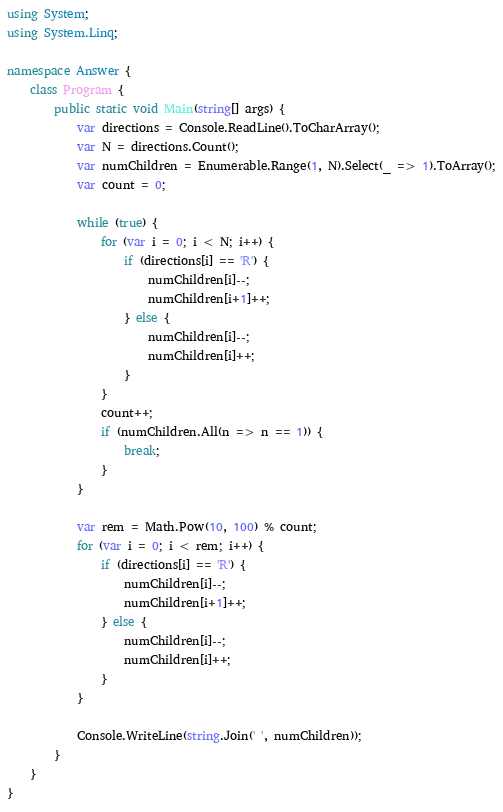<code> <loc_0><loc_0><loc_500><loc_500><_C#_>using System;
using System.Linq;

namespace Answer {
    class Program {
        public static void Main(string[] args) {
            var directions = Console.ReadLine().ToCharArray();
            var N = directions.Count();
            var numChildren = Enumerable.Range(1, N).Select(_ => 1).ToArray();
            var count = 0;

            while (true) {
                for (var i = 0; i < N; i++) {
                    if (directions[i] == 'R') {
                        numChildren[i]--;
                        numChildren[i+1]++;
                    } else {
                        numChildren[i]--;
                        numChildren[i]++;
                    }
                }
                count++;
                if (numChildren.All(n => n == 1)) {
                    break;
                }
            }

            var rem = Math.Pow(10, 100) % count;
            for (var i = 0; i < rem; i++) {
                if (directions[i] == 'R') {
                    numChildren[i]--;
                    numChildren[i+1]++;
                } else {
                    numChildren[i]--;
                    numChildren[i]++;
                }
            }

            Console.WriteLine(string.Join(' ', numChildren));
        }
    }
}
</code> 